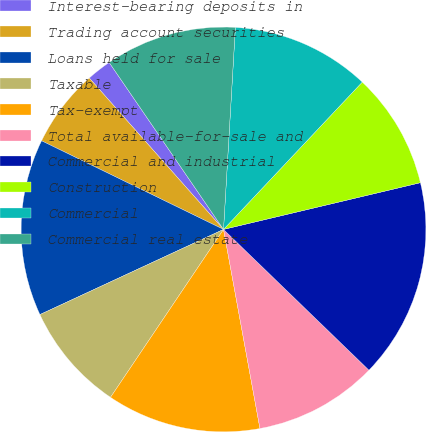<chart> <loc_0><loc_0><loc_500><loc_500><pie_chart><fcel>Interest-bearing deposits in<fcel>Trading account securities<fcel>Loans held for sale<fcel>Taxable<fcel>Tax-exempt<fcel>Total available-for-sale and<fcel>Commercial and industrial<fcel>Construction<fcel>Commercial<fcel>Commercial real estate<nl><fcel>1.99%<fcel>6.24%<fcel>14.13%<fcel>8.66%<fcel>12.31%<fcel>9.88%<fcel>15.95%<fcel>9.27%<fcel>11.09%<fcel>10.49%<nl></chart> 